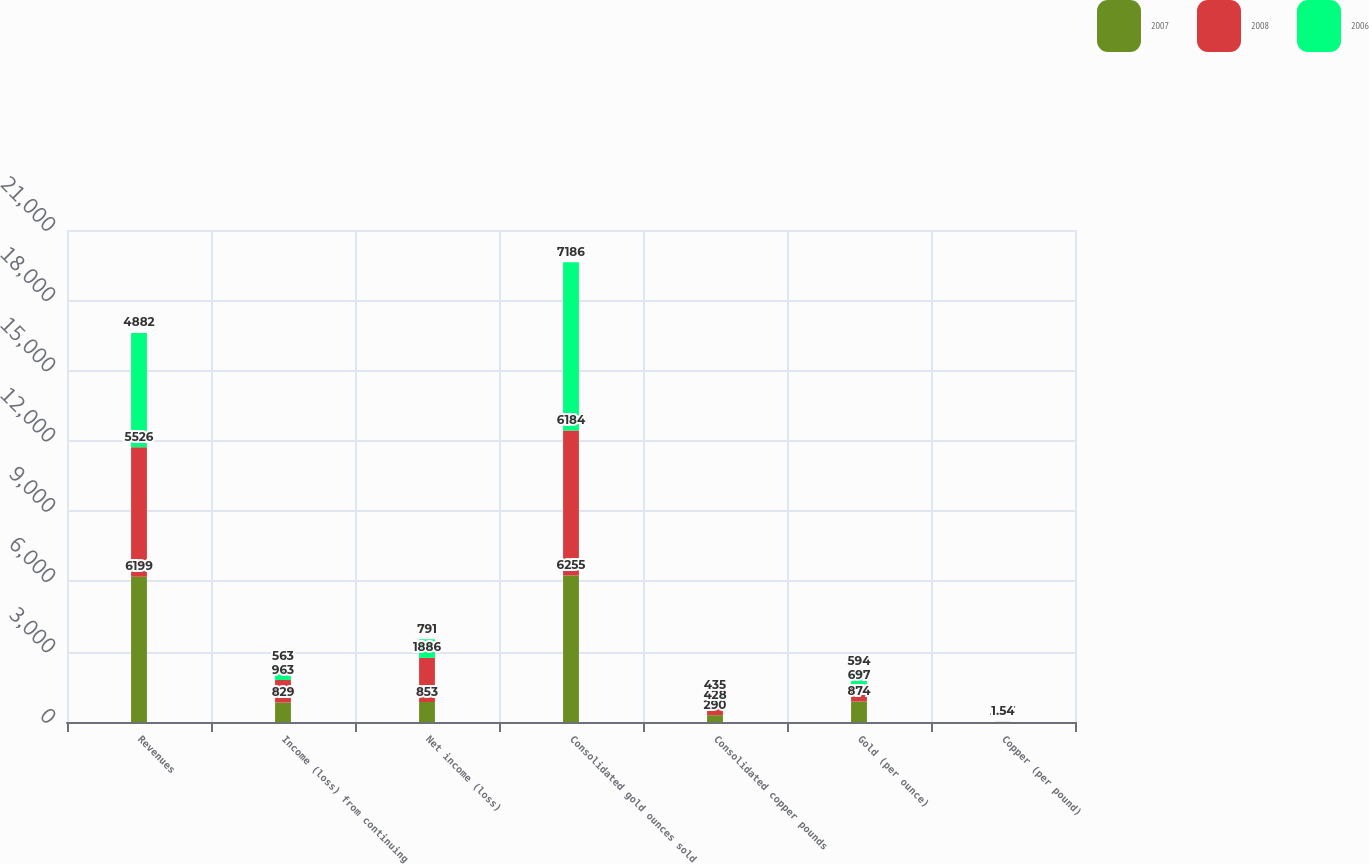<chart> <loc_0><loc_0><loc_500><loc_500><stacked_bar_chart><ecel><fcel>Revenues<fcel>Income (loss) from continuing<fcel>Net income (loss)<fcel>Consolidated gold ounces sold<fcel>Consolidated copper pounds<fcel>Gold (per ounce)<fcel>Copper (per pound)<nl><fcel>2007<fcel>6199<fcel>829<fcel>853<fcel>6255<fcel>290<fcel>874<fcel>2.59<nl><fcel>2008<fcel>5526<fcel>963<fcel>1886<fcel>6184<fcel>428<fcel>697<fcel>2.86<nl><fcel>2006<fcel>4882<fcel>563<fcel>791<fcel>7186<fcel>435<fcel>594<fcel>1.54<nl></chart> 